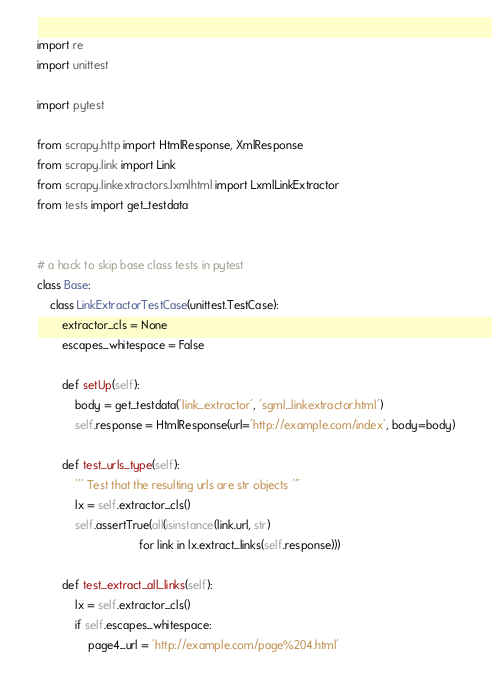Convert code to text. <code><loc_0><loc_0><loc_500><loc_500><_Python_>import re
import unittest

import pytest

from scrapy.http import HtmlResponse, XmlResponse
from scrapy.link import Link
from scrapy.linkextractors.lxmlhtml import LxmlLinkExtractor
from tests import get_testdata


# a hack to skip base class tests in pytest
class Base:
    class LinkExtractorTestCase(unittest.TestCase):
        extractor_cls = None
        escapes_whitespace = False

        def setUp(self):
            body = get_testdata('link_extractor', 'sgml_linkextractor.html')
            self.response = HtmlResponse(url='http://example.com/index', body=body)

        def test_urls_type(self):
            ''' Test that the resulting urls are str objects '''
            lx = self.extractor_cls()
            self.assertTrue(all(isinstance(link.url, str)
                                for link in lx.extract_links(self.response)))

        def test_extract_all_links(self):
            lx = self.extractor_cls()
            if self.escapes_whitespace:
                page4_url = 'http://example.com/page%204.html'</code> 